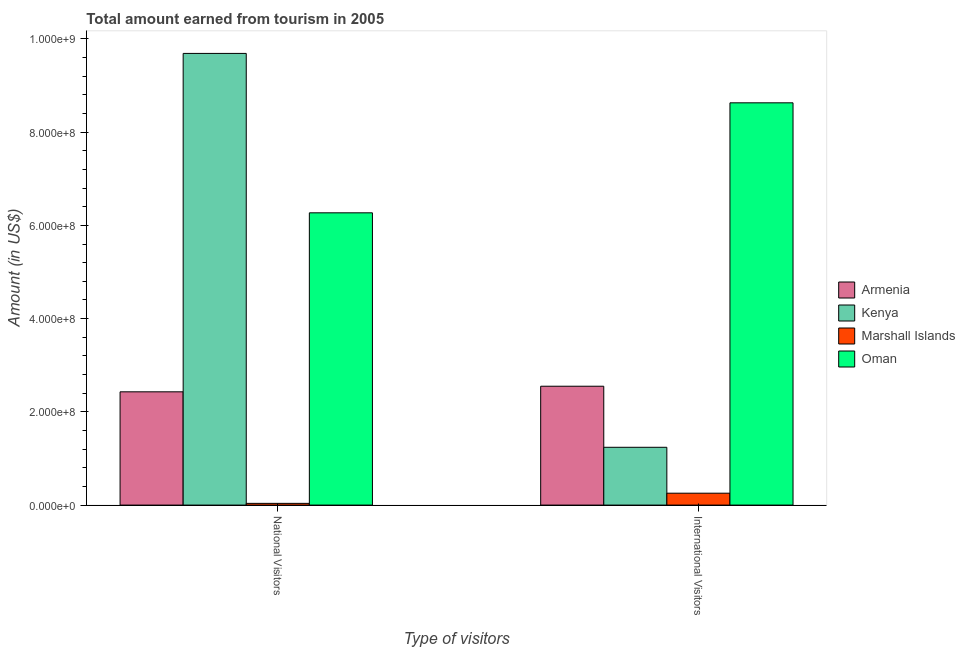How many groups of bars are there?
Ensure brevity in your answer.  2. Are the number of bars on each tick of the X-axis equal?
Keep it short and to the point. Yes. How many bars are there on the 2nd tick from the left?
Provide a succinct answer. 4. What is the label of the 1st group of bars from the left?
Your answer should be compact. National Visitors. What is the amount earned from international visitors in Oman?
Offer a very short reply. 8.63e+08. Across all countries, what is the maximum amount earned from national visitors?
Your answer should be compact. 9.69e+08. Across all countries, what is the minimum amount earned from international visitors?
Offer a very short reply. 2.55e+07. In which country was the amount earned from national visitors maximum?
Your response must be concise. Kenya. In which country was the amount earned from national visitors minimum?
Your response must be concise. Marshall Islands. What is the total amount earned from international visitors in the graph?
Your answer should be compact. 1.27e+09. What is the difference between the amount earned from national visitors in Armenia and that in Marshall Islands?
Your answer should be compact. 2.39e+08. What is the difference between the amount earned from international visitors in Oman and the amount earned from national visitors in Kenya?
Offer a terse response. -1.06e+08. What is the average amount earned from national visitors per country?
Your answer should be compact. 4.61e+08. What is the difference between the amount earned from international visitors and amount earned from national visitors in Kenya?
Provide a succinct answer. -8.45e+08. In how many countries, is the amount earned from international visitors greater than 640000000 US$?
Give a very brief answer. 1. What is the ratio of the amount earned from national visitors in Armenia to that in Marshall Islands?
Make the answer very short. 65.85. What does the 2nd bar from the left in National Visitors represents?
Your response must be concise. Kenya. What does the 1st bar from the right in National Visitors represents?
Make the answer very short. Oman. How many bars are there?
Your answer should be very brief. 8. Are all the bars in the graph horizontal?
Keep it short and to the point. No. Are the values on the major ticks of Y-axis written in scientific E-notation?
Ensure brevity in your answer.  Yes. Does the graph contain grids?
Offer a very short reply. No. Where does the legend appear in the graph?
Keep it short and to the point. Center right. What is the title of the graph?
Offer a terse response. Total amount earned from tourism in 2005. Does "Algeria" appear as one of the legend labels in the graph?
Your answer should be compact. No. What is the label or title of the X-axis?
Offer a terse response. Type of visitors. What is the label or title of the Y-axis?
Keep it short and to the point. Amount (in US$). What is the Amount (in US$) in Armenia in National Visitors?
Provide a succinct answer. 2.43e+08. What is the Amount (in US$) in Kenya in National Visitors?
Offer a very short reply. 9.69e+08. What is the Amount (in US$) in Marshall Islands in National Visitors?
Make the answer very short. 3.69e+06. What is the Amount (in US$) of Oman in National Visitors?
Make the answer very short. 6.27e+08. What is the Amount (in US$) in Armenia in International Visitors?
Your answer should be very brief. 2.55e+08. What is the Amount (in US$) in Kenya in International Visitors?
Provide a succinct answer. 1.24e+08. What is the Amount (in US$) in Marshall Islands in International Visitors?
Provide a short and direct response. 2.55e+07. What is the Amount (in US$) in Oman in International Visitors?
Offer a very short reply. 8.63e+08. Across all Type of visitors, what is the maximum Amount (in US$) in Armenia?
Your answer should be very brief. 2.55e+08. Across all Type of visitors, what is the maximum Amount (in US$) in Kenya?
Your response must be concise. 9.69e+08. Across all Type of visitors, what is the maximum Amount (in US$) in Marshall Islands?
Provide a succinct answer. 2.55e+07. Across all Type of visitors, what is the maximum Amount (in US$) in Oman?
Make the answer very short. 8.63e+08. Across all Type of visitors, what is the minimum Amount (in US$) of Armenia?
Ensure brevity in your answer.  2.43e+08. Across all Type of visitors, what is the minimum Amount (in US$) in Kenya?
Make the answer very short. 1.24e+08. Across all Type of visitors, what is the minimum Amount (in US$) in Marshall Islands?
Ensure brevity in your answer.  3.69e+06. Across all Type of visitors, what is the minimum Amount (in US$) of Oman?
Your answer should be very brief. 6.27e+08. What is the total Amount (in US$) of Armenia in the graph?
Give a very brief answer. 4.98e+08. What is the total Amount (in US$) of Kenya in the graph?
Give a very brief answer. 1.09e+09. What is the total Amount (in US$) of Marshall Islands in the graph?
Provide a short and direct response. 2.92e+07. What is the total Amount (in US$) in Oman in the graph?
Offer a terse response. 1.49e+09. What is the difference between the Amount (in US$) in Armenia in National Visitors and that in International Visitors?
Your answer should be compact. -1.20e+07. What is the difference between the Amount (in US$) in Kenya in National Visitors and that in International Visitors?
Ensure brevity in your answer.  8.45e+08. What is the difference between the Amount (in US$) of Marshall Islands in National Visitors and that in International Visitors?
Your answer should be compact. -2.18e+07. What is the difference between the Amount (in US$) of Oman in National Visitors and that in International Visitors?
Ensure brevity in your answer.  -2.36e+08. What is the difference between the Amount (in US$) in Armenia in National Visitors and the Amount (in US$) in Kenya in International Visitors?
Give a very brief answer. 1.19e+08. What is the difference between the Amount (in US$) of Armenia in National Visitors and the Amount (in US$) of Marshall Islands in International Visitors?
Make the answer very short. 2.18e+08. What is the difference between the Amount (in US$) of Armenia in National Visitors and the Amount (in US$) of Oman in International Visitors?
Provide a succinct answer. -6.20e+08. What is the difference between the Amount (in US$) in Kenya in National Visitors and the Amount (in US$) in Marshall Islands in International Visitors?
Provide a succinct answer. 9.44e+08. What is the difference between the Amount (in US$) in Kenya in National Visitors and the Amount (in US$) in Oman in International Visitors?
Your answer should be very brief. 1.06e+08. What is the difference between the Amount (in US$) of Marshall Islands in National Visitors and the Amount (in US$) of Oman in International Visitors?
Give a very brief answer. -8.59e+08. What is the average Amount (in US$) of Armenia per Type of visitors?
Offer a terse response. 2.49e+08. What is the average Amount (in US$) of Kenya per Type of visitors?
Ensure brevity in your answer.  5.46e+08. What is the average Amount (in US$) in Marshall Islands per Type of visitors?
Offer a terse response. 1.46e+07. What is the average Amount (in US$) in Oman per Type of visitors?
Your answer should be compact. 7.45e+08. What is the difference between the Amount (in US$) in Armenia and Amount (in US$) in Kenya in National Visitors?
Make the answer very short. -7.26e+08. What is the difference between the Amount (in US$) of Armenia and Amount (in US$) of Marshall Islands in National Visitors?
Give a very brief answer. 2.39e+08. What is the difference between the Amount (in US$) of Armenia and Amount (in US$) of Oman in National Visitors?
Offer a terse response. -3.84e+08. What is the difference between the Amount (in US$) of Kenya and Amount (in US$) of Marshall Islands in National Visitors?
Keep it short and to the point. 9.65e+08. What is the difference between the Amount (in US$) in Kenya and Amount (in US$) in Oman in National Visitors?
Provide a succinct answer. 3.42e+08. What is the difference between the Amount (in US$) in Marshall Islands and Amount (in US$) in Oman in National Visitors?
Keep it short and to the point. -6.23e+08. What is the difference between the Amount (in US$) in Armenia and Amount (in US$) in Kenya in International Visitors?
Offer a very short reply. 1.31e+08. What is the difference between the Amount (in US$) of Armenia and Amount (in US$) of Marshall Islands in International Visitors?
Provide a short and direct response. 2.30e+08. What is the difference between the Amount (in US$) in Armenia and Amount (in US$) in Oman in International Visitors?
Give a very brief answer. -6.08e+08. What is the difference between the Amount (in US$) in Kenya and Amount (in US$) in Marshall Islands in International Visitors?
Your response must be concise. 9.85e+07. What is the difference between the Amount (in US$) of Kenya and Amount (in US$) of Oman in International Visitors?
Your answer should be compact. -7.39e+08. What is the difference between the Amount (in US$) of Marshall Islands and Amount (in US$) of Oman in International Visitors?
Provide a succinct answer. -8.38e+08. What is the ratio of the Amount (in US$) of Armenia in National Visitors to that in International Visitors?
Your response must be concise. 0.95. What is the ratio of the Amount (in US$) of Kenya in National Visitors to that in International Visitors?
Offer a terse response. 7.81. What is the ratio of the Amount (in US$) of Marshall Islands in National Visitors to that in International Visitors?
Make the answer very short. 0.14. What is the ratio of the Amount (in US$) of Oman in National Visitors to that in International Visitors?
Your answer should be compact. 0.73. What is the difference between the highest and the second highest Amount (in US$) in Kenya?
Your answer should be very brief. 8.45e+08. What is the difference between the highest and the second highest Amount (in US$) of Marshall Islands?
Make the answer very short. 2.18e+07. What is the difference between the highest and the second highest Amount (in US$) in Oman?
Offer a terse response. 2.36e+08. What is the difference between the highest and the lowest Amount (in US$) in Armenia?
Keep it short and to the point. 1.20e+07. What is the difference between the highest and the lowest Amount (in US$) of Kenya?
Keep it short and to the point. 8.45e+08. What is the difference between the highest and the lowest Amount (in US$) in Marshall Islands?
Offer a very short reply. 2.18e+07. What is the difference between the highest and the lowest Amount (in US$) in Oman?
Offer a terse response. 2.36e+08. 